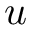<formula> <loc_0><loc_0><loc_500><loc_500>u</formula> 